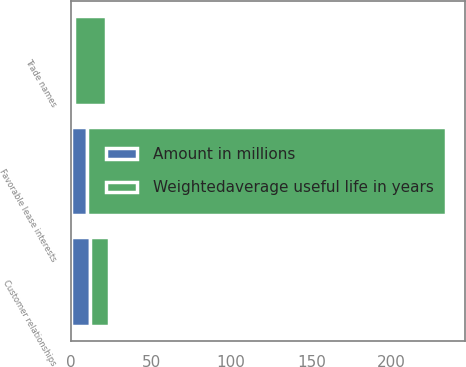<chart> <loc_0><loc_0><loc_500><loc_500><stacked_bar_chart><ecel><fcel>Customer relationships<fcel>Favorable lease interests<fcel>Trade names<nl><fcel>Amount in millions<fcel>12<fcel>10<fcel>2<nl><fcel>Weightedaverage useful life in years<fcel>12<fcel>224<fcel>20<nl></chart> 